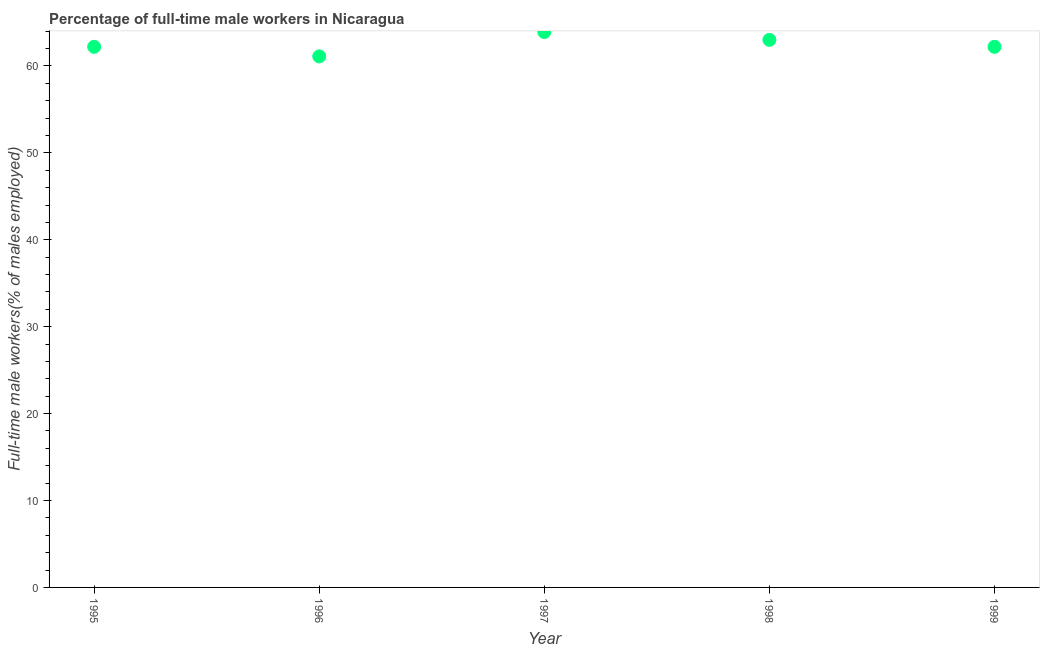Across all years, what is the maximum percentage of full-time male workers?
Provide a succinct answer. 63.9. Across all years, what is the minimum percentage of full-time male workers?
Your response must be concise. 61.1. In which year was the percentage of full-time male workers minimum?
Your answer should be very brief. 1996. What is the sum of the percentage of full-time male workers?
Your answer should be very brief. 312.4. What is the difference between the percentage of full-time male workers in 1996 and 1999?
Your response must be concise. -1.1. What is the average percentage of full-time male workers per year?
Your response must be concise. 62.48. What is the median percentage of full-time male workers?
Ensure brevity in your answer.  62.2. In how many years, is the percentage of full-time male workers greater than 24 %?
Make the answer very short. 5. What is the ratio of the percentage of full-time male workers in 1996 to that in 1999?
Make the answer very short. 0.98. Is the difference between the percentage of full-time male workers in 1998 and 1999 greater than the difference between any two years?
Offer a terse response. No. What is the difference between the highest and the second highest percentage of full-time male workers?
Keep it short and to the point. 0.9. What is the difference between the highest and the lowest percentage of full-time male workers?
Keep it short and to the point. 2.8. In how many years, is the percentage of full-time male workers greater than the average percentage of full-time male workers taken over all years?
Your answer should be very brief. 2. Does the percentage of full-time male workers monotonically increase over the years?
Keep it short and to the point. No. How many dotlines are there?
Offer a terse response. 1. How many years are there in the graph?
Ensure brevity in your answer.  5. Are the values on the major ticks of Y-axis written in scientific E-notation?
Give a very brief answer. No. Does the graph contain any zero values?
Your answer should be compact. No. Does the graph contain grids?
Ensure brevity in your answer.  No. What is the title of the graph?
Give a very brief answer. Percentage of full-time male workers in Nicaragua. What is the label or title of the Y-axis?
Provide a succinct answer. Full-time male workers(% of males employed). What is the Full-time male workers(% of males employed) in 1995?
Offer a very short reply. 62.2. What is the Full-time male workers(% of males employed) in 1996?
Provide a short and direct response. 61.1. What is the Full-time male workers(% of males employed) in 1997?
Ensure brevity in your answer.  63.9. What is the Full-time male workers(% of males employed) in 1999?
Provide a succinct answer. 62.2. What is the difference between the Full-time male workers(% of males employed) in 1995 and 1996?
Provide a short and direct response. 1.1. What is the difference between the Full-time male workers(% of males employed) in 1995 and 1997?
Ensure brevity in your answer.  -1.7. What is the difference between the Full-time male workers(% of males employed) in 1995 and 1999?
Give a very brief answer. 0. What is the difference between the Full-time male workers(% of males employed) in 1996 and 1997?
Your answer should be compact. -2.8. What is the difference between the Full-time male workers(% of males employed) in 1996 and 1998?
Your response must be concise. -1.9. What is the difference between the Full-time male workers(% of males employed) in 1996 and 1999?
Make the answer very short. -1.1. What is the difference between the Full-time male workers(% of males employed) in 1997 and 1998?
Your answer should be compact. 0.9. What is the ratio of the Full-time male workers(% of males employed) in 1995 to that in 1997?
Provide a succinct answer. 0.97. What is the ratio of the Full-time male workers(% of males employed) in 1995 to that in 1998?
Your answer should be very brief. 0.99. What is the ratio of the Full-time male workers(% of males employed) in 1996 to that in 1997?
Ensure brevity in your answer.  0.96. What is the ratio of the Full-time male workers(% of males employed) in 1996 to that in 1999?
Your answer should be very brief. 0.98. What is the ratio of the Full-time male workers(% of males employed) in 1997 to that in 1998?
Your answer should be very brief. 1.01. 